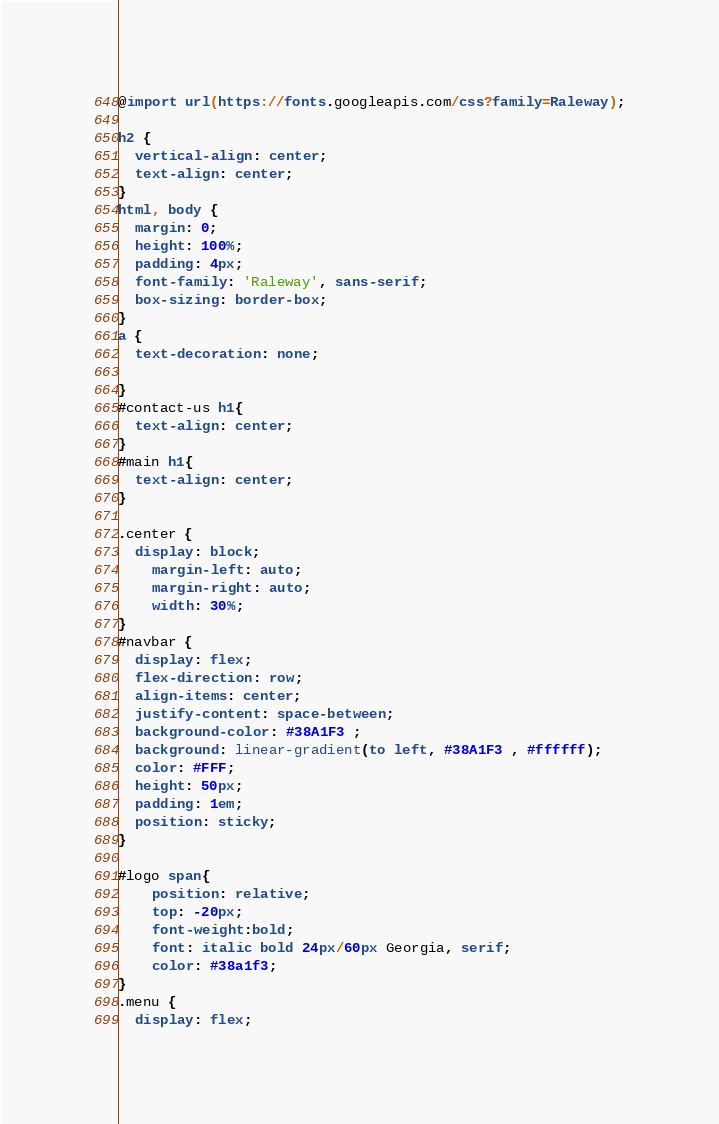Convert code to text. <code><loc_0><loc_0><loc_500><loc_500><_CSS_>@import url(https://fonts.googleapis.com/css?family=Raleway);

h2 {
  vertical-align: center;
  text-align: center;
}
html, body {
  margin: 0;
  height: 100%;
  padding: 4px;
  font-family: 'Raleway', sans-serif;
  box-sizing: border-box;
}
a {
  text-decoration: none;

}
#contact-us h1{
  text-align: center;
}
#main h1{
  text-align: center;
}

.center {
  display: block;
    margin-left: auto;
    margin-right: auto;
    width: 30%;
}
#navbar {
  display: flex;
  flex-direction: row;
  align-items: center;
  justify-content: space-between;
  background-color: #38A1F3 ;
  background: linear-gradient(to left, #38A1F3 , #ffffff);
  color: #FFF;
  height: 50px;
  padding: 1em;
  position: sticky;
}

#logo span{
    position: relative;
    top: -20px;
    font-weight:bold;
    font: italic bold 24px/60px Georgia, serif;
    color: #38a1f3;
}
.menu {
  display: flex;</code> 